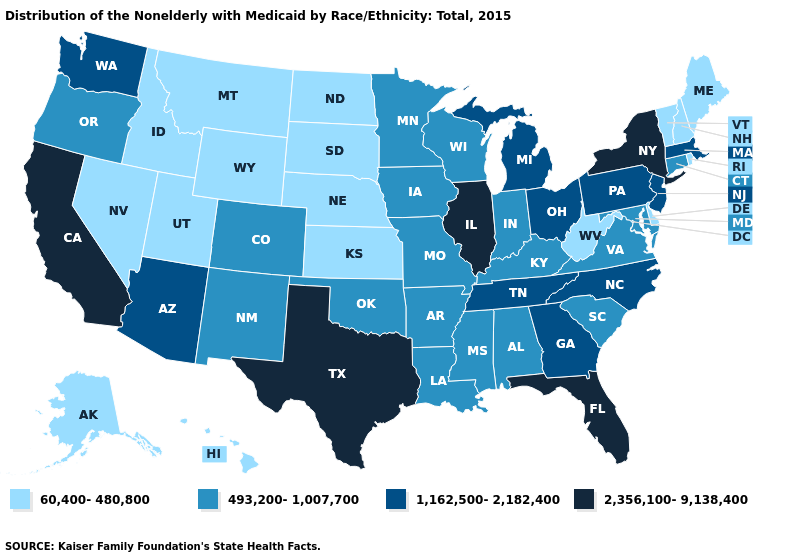Does Connecticut have the highest value in the USA?
Give a very brief answer. No. Does Idaho have the highest value in the USA?
Quick response, please. No. What is the value of Texas?
Short answer required. 2,356,100-9,138,400. What is the value of Nevada?
Answer briefly. 60,400-480,800. What is the lowest value in states that border Maine?
Write a very short answer. 60,400-480,800. Name the states that have a value in the range 493,200-1,007,700?
Quick response, please. Alabama, Arkansas, Colorado, Connecticut, Indiana, Iowa, Kentucky, Louisiana, Maryland, Minnesota, Mississippi, Missouri, New Mexico, Oklahoma, Oregon, South Carolina, Virginia, Wisconsin. What is the lowest value in the South?
Answer briefly. 60,400-480,800. Among the states that border South Dakota , which have the lowest value?
Answer briefly. Montana, Nebraska, North Dakota, Wyoming. Does Utah have a higher value than Iowa?
Quick response, please. No. Does California have the highest value in the USA?
Answer briefly. Yes. What is the value of Minnesota?
Write a very short answer. 493,200-1,007,700. Name the states that have a value in the range 60,400-480,800?
Write a very short answer. Alaska, Delaware, Hawaii, Idaho, Kansas, Maine, Montana, Nebraska, Nevada, New Hampshire, North Dakota, Rhode Island, South Dakota, Utah, Vermont, West Virginia, Wyoming. Name the states that have a value in the range 1,162,500-2,182,400?
Give a very brief answer. Arizona, Georgia, Massachusetts, Michigan, New Jersey, North Carolina, Ohio, Pennsylvania, Tennessee, Washington. Among the states that border Michigan , does Indiana have the highest value?
Concise answer only. No. What is the highest value in the USA?
Write a very short answer. 2,356,100-9,138,400. 